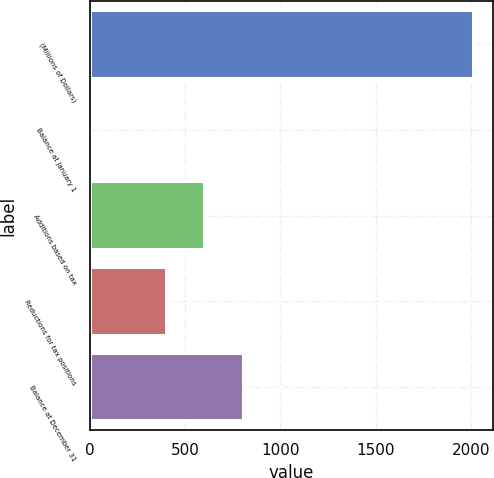Convert chart to OTSL. <chart><loc_0><loc_0><loc_500><loc_500><bar_chart><fcel>(Millions of Dollars)<fcel>Balance at January 1<fcel>Additions based on tax<fcel>Reductions for tax positions<fcel>Balance at December 31<nl><fcel>2016<fcel>2<fcel>606.2<fcel>404.8<fcel>807.6<nl></chart> 